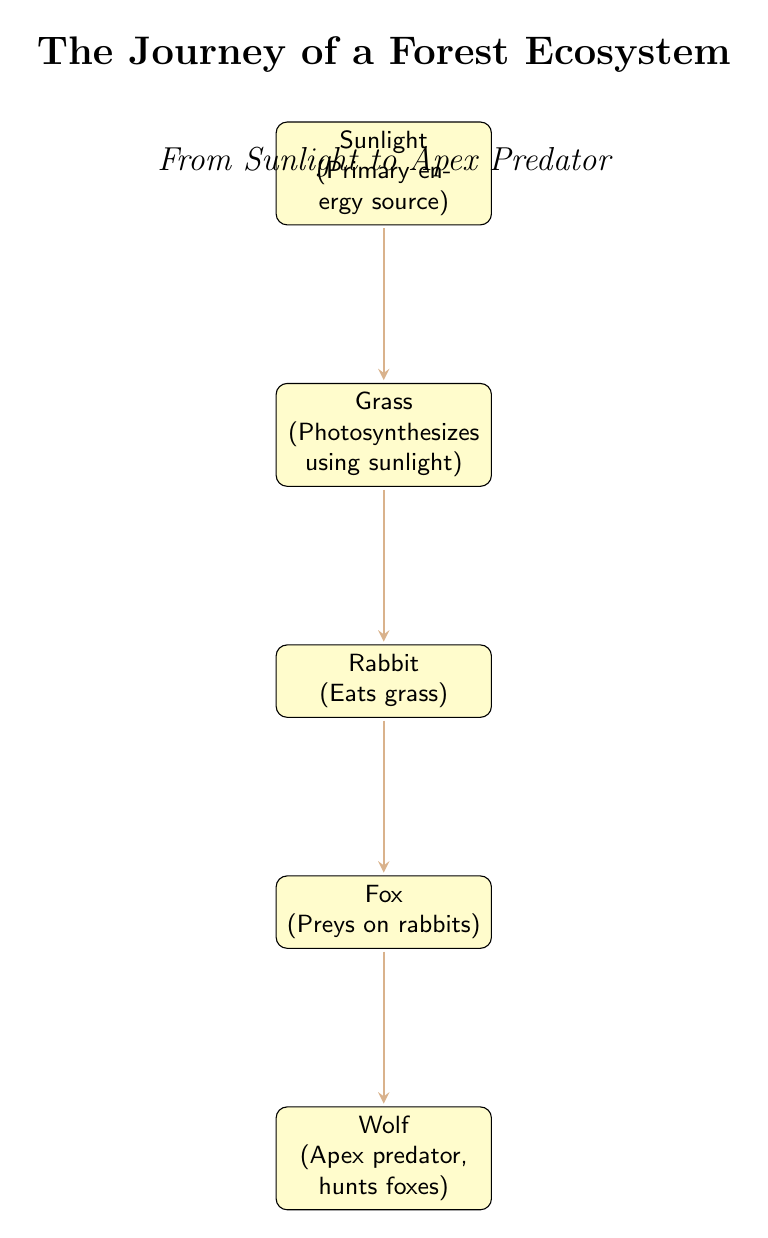What is the primary energy source in this ecosystem? The diagram identifies "Sunlight" as the primary energy source at the top. This node is the starting point of the food chain.
Answer: Sunlight How many levels are there in the food chain? By counting the nodes in the diagram, we see five distinct levels: Sunlight, Grass, Rabbit, Fox, and Wolf. Therefore, there are five levels in total.
Answer: 5 What does the rabbit consume? The arrow from the "Grass" node points to the "Rabbit" node, indicating that the rabbit eats grass.
Answer: Grass Which organism is at the top of the food chain? The bottommost node "Wolf" represents the apex predator in this ecosystem, making it the top organism in the food chain.
Answer: Wolf What type of organism is the fox in this ecosystem? The diagram states that the fox "Preys on rabbits," indicating that it is a predator in this food chain.
Answer: Predator What is the relationship between the rabbit and the fox? The arrow between the rabbit and the fox indicates a predatory relationship, where the fox hunts the rabbit for food.
Answer: Prey If sunlight is blocked, which organism would be affected first? The first organism directly dependent on sunlight is the "Grass," as it requires sunlight for photosynthesis to grow.
Answer: Grass Who hunts the foxes in this ecosystem? The diagram shows that the "Wolf" preys on the foxes, as indicated by the arrow pointing from the fox to the wolf.
Answer: Wolf How does grass obtain energy? The diagram explicitly states that grass "Photosynthesizes using sunlight," indicating that it converts sunlight into energy through the process of photosynthesis.
Answer: Photosynthesis 